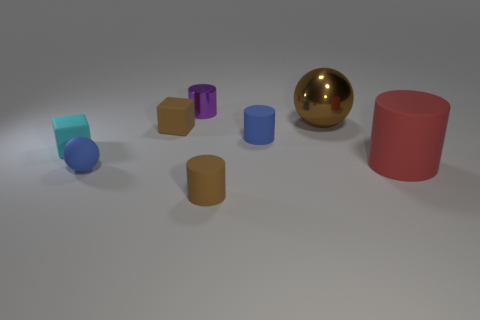Add 1 small purple metal things. How many objects exist? 9 Subtract all cubes. How many objects are left? 6 Add 5 small cyan rubber objects. How many small cyan rubber objects are left? 6 Add 5 brown matte cubes. How many brown matte cubes exist? 6 Subtract 0 yellow cylinders. How many objects are left? 8 Subtract all blue spheres. Subtract all large cylinders. How many objects are left? 6 